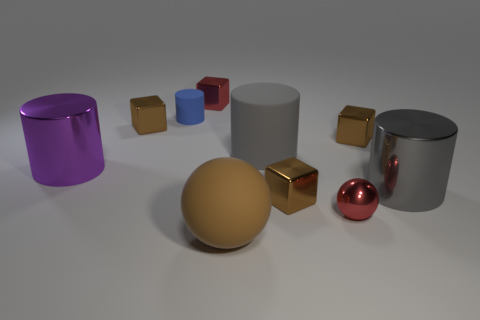Subtract all brown spheres. How many brown cubes are left? 3 Subtract all cylinders. How many objects are left? 6 Add 7 purple things. How many purple things are left? 8 Add 9 metal spheres. How many metal spheres exist? 10 Subtract 0 gray spheres. How many objects are left? 10 Subtract all blue cylinders. Subtract all large gray cylinders. How many objects are left? 7 